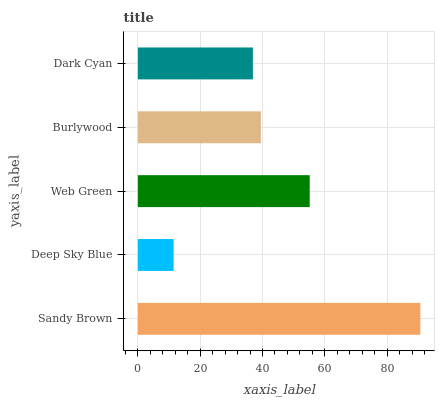Is Deep Sky Blue the minimum?
Answer yes or no. Yes. Is Sandy Brown the maximum?
Answer yes or no. Yes. Is Web Green the minimum?
Answer yes or no. No. Is Web Green the maximum?
Answer yes or no. No. Is Web Green greater than Deep Sky Blue?
Answer yes or no. Yes. Is Deep Sky Blue less than Web Green?
Answer yes or no. Yes. Is Deep Sky Blue greater than Web Green?
Answer yes or no. No. Is Web Green less than Deep Sky Blue?
Answer yes or no. No. Is Burlywood the high median?
Answer yes or no. Yes. Is Burlywood the low median?
Answer yes or no. Yes. Is Web Green the high median?
Answer yes or no. No. Is Sandy Brown the low median?
Answer yes or no. No. 